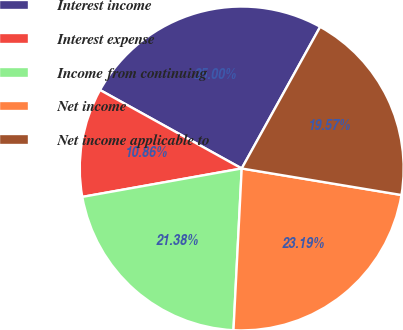Convert chart. <chart><loc_0><loc_0><loc_500><loc_500><pie_chart><fcel>Interest income<fcel>Interest expense<fcel>Income from continuing<fcel>Net income<fcel>Net income applicable to<nl><fcel>25.0%<fcel>10.86%<fcel>21.38%<fcel>23.19%<fcel>19.57%<nl></chart> 